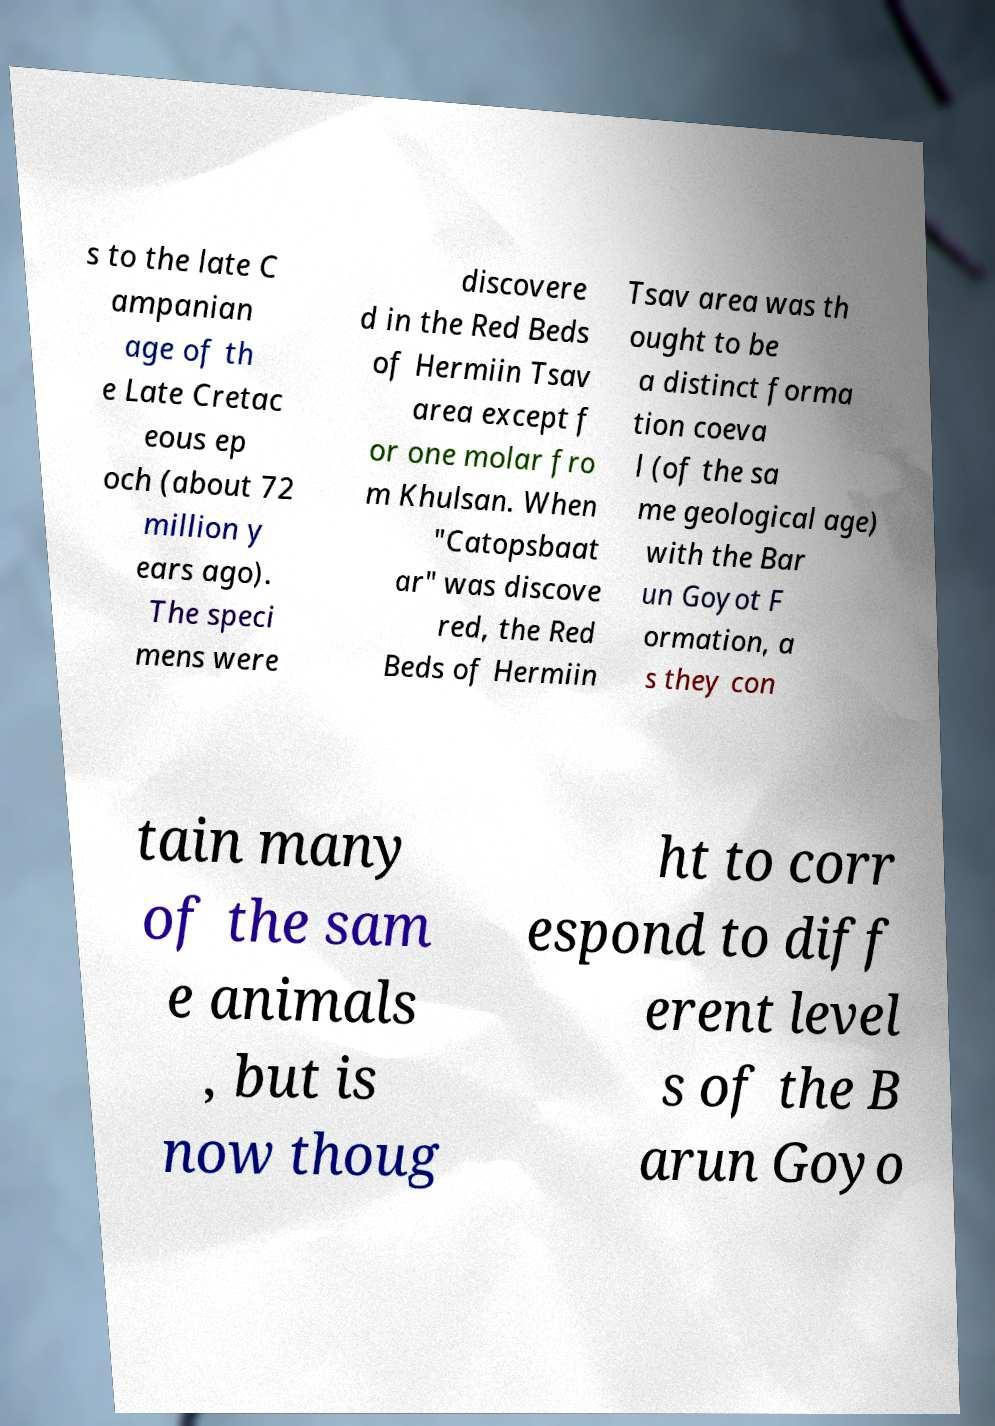Can you accurately transcribe the text from the provided image for me? s to the late C ampanian age of th e Late Cretac eous ep och (about 72 million y ears ago). The speci mens were discovere d in the Red Beds of Hermiin Tsav area except f or one molar fro m Khulsan. When "Catopsbaat ar" was discove red, the Red Beds of Hermiin Tsav area was th ought to be a distinct forma tion coeva l (of the sa me geological age) with the Bar un Goyot F ormation, a s they con tain many of the sam e animals , but is now thoug ht to corr espond to diff erent level s of the B arun Goyo 